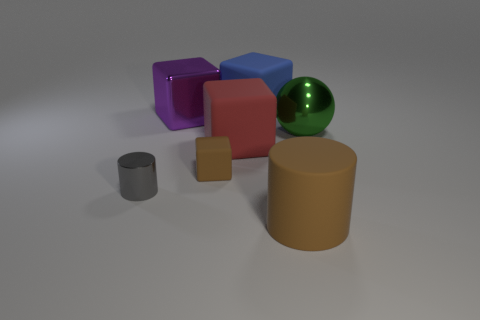Subtract all big blue matte blocks. How many blocks are left? 3 Subtract 1 spheres. How many spheres are left? 0 Add 1 tiny green metallic spheres. How many objects exist? 8 Subtract all gray cylinders. How many cylinders are left? 1 Subtract 1 purple cubes. How many objects are left? 6 Subtract all blocks. How many objects are left? 3 Subtract all gray spheres. Subtract all green cubes. How many spheres are left? 1 Subtract all gray rubber objects. Subtract all large things. How many objects are left? 2 Add 2 green balls. How many green balls are left? 3 Add 1 big green cylinders. How many big green cylinders exist? 1 